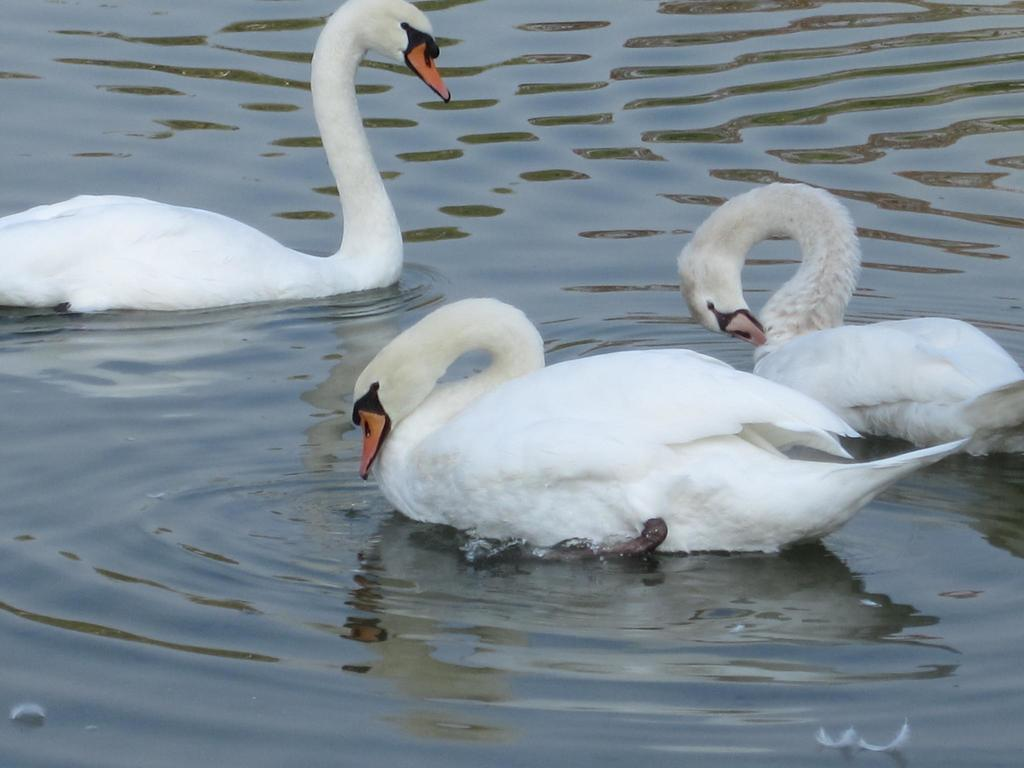What animals are in the center of the image? There are three swans in the center of the image. What is visible in the background of the image? There is water visible in the background of the image. What shape is the bed in the image? There is no bed present in the image. 